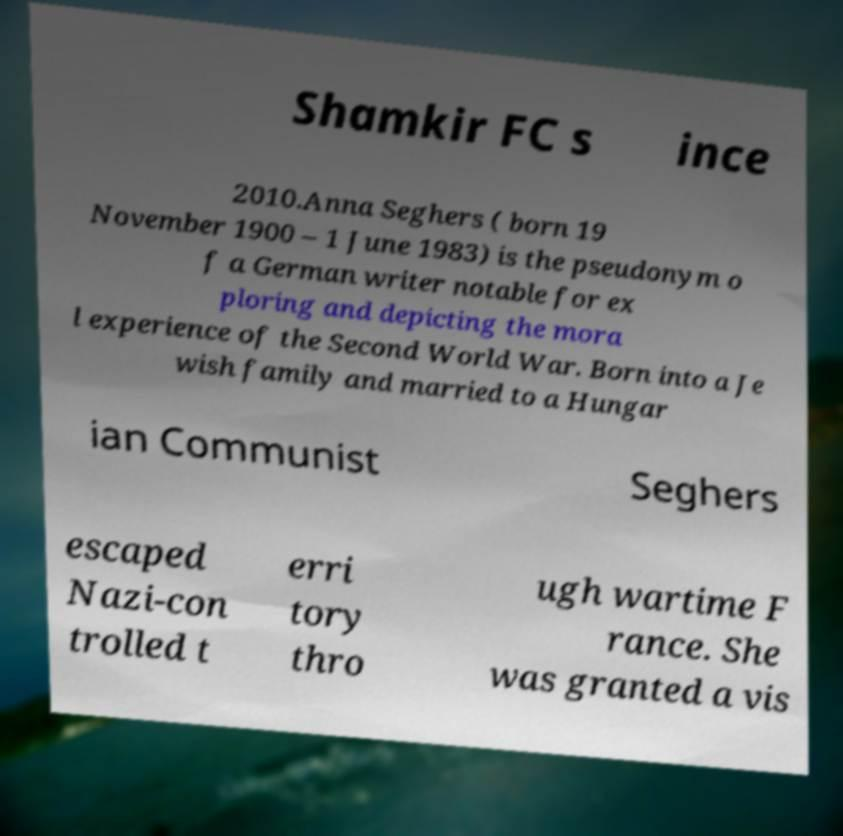Please identify and transcribe the text found in this image. Shamkir FC s ince 2010.Anna Seghers ( born 19 November 1900 – 1 June 1983) is the pseudonym o f a German writer notable for ex ploring and depicting the mora l experience of the Second World War. Born into a Je wish family and married to a Hungar ian Communist Seghers escaped Nazi-con trolled t erri tory thro ugh wartime F rance. She was granted a vis 